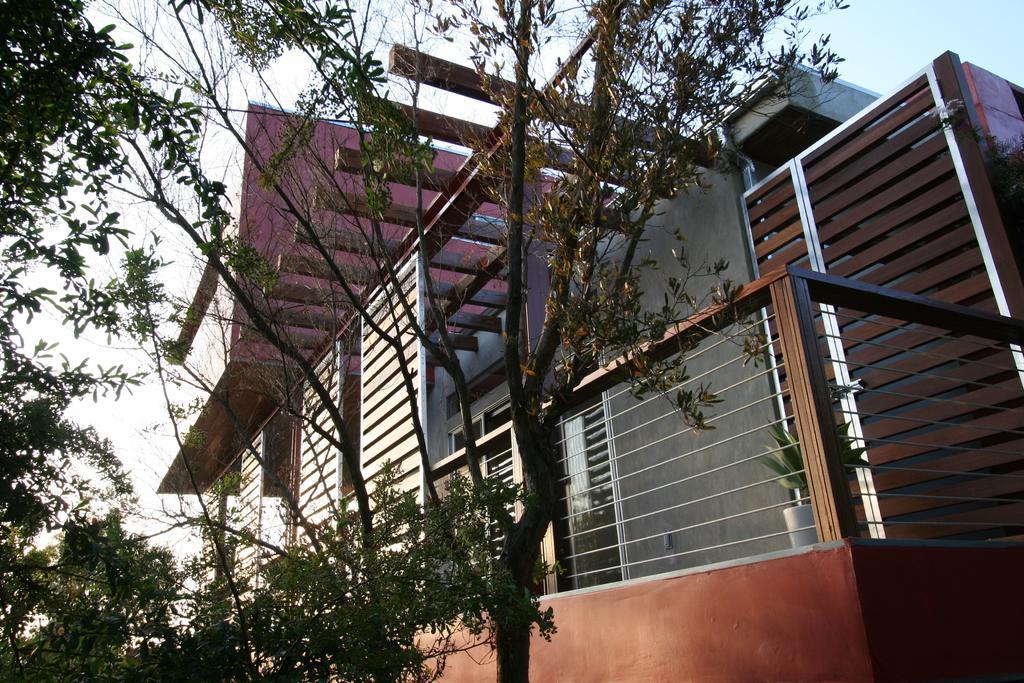How would you summarize this image in a sentence or two? In this picture we can see a building and a houseplant in this building. We can see a few trees on the left side. 